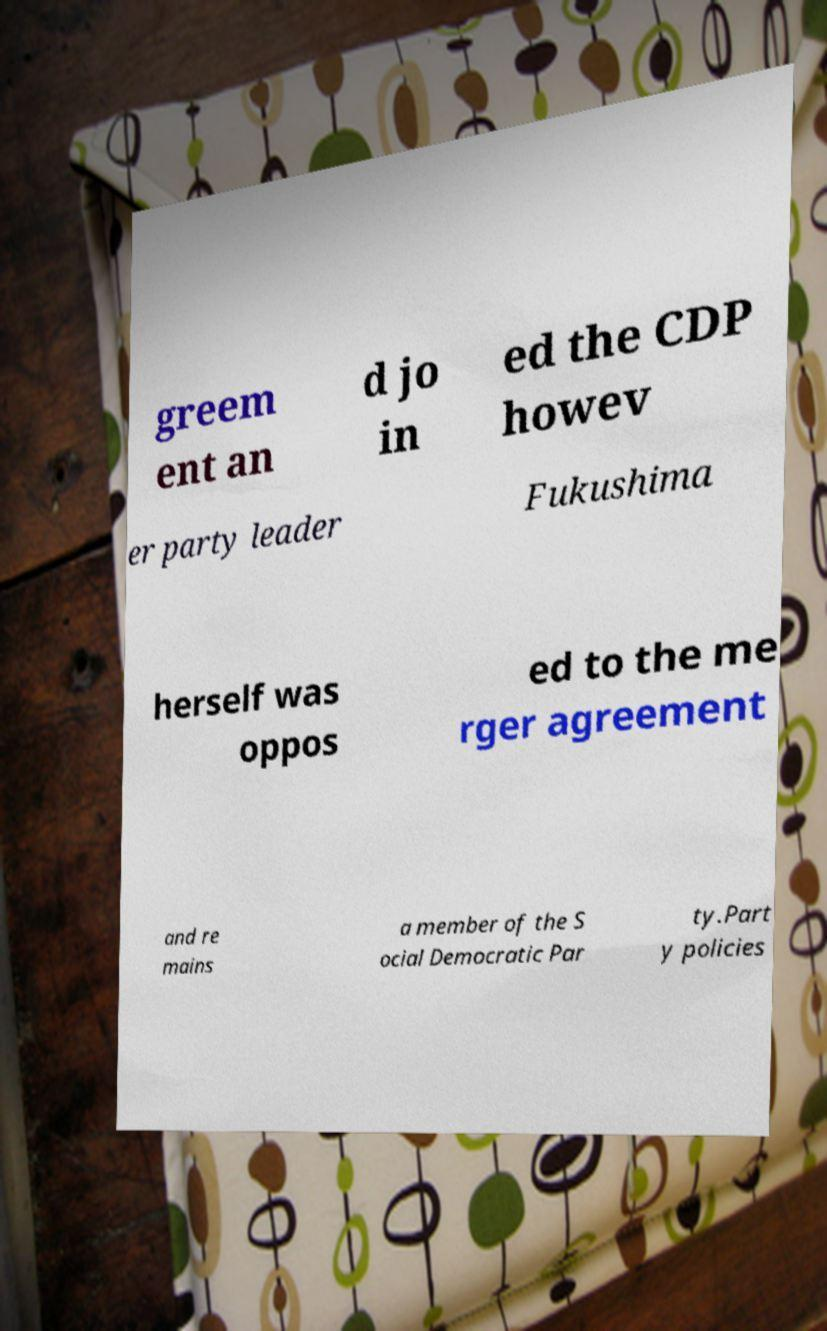Please read and relay the text visible in this image. What does it say? greem ent an d jo in ed the CDP howev er party leader Fukushima herself was oppos ed to the me rger agreement and re mains a member of the S ocial Democratic Par ty.Part y policies 